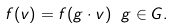<formula> <loc_0><loc_0><loc_500><loc_500>f ( v ) = f ( g \cdot v ) \ g \in G .</formula> 